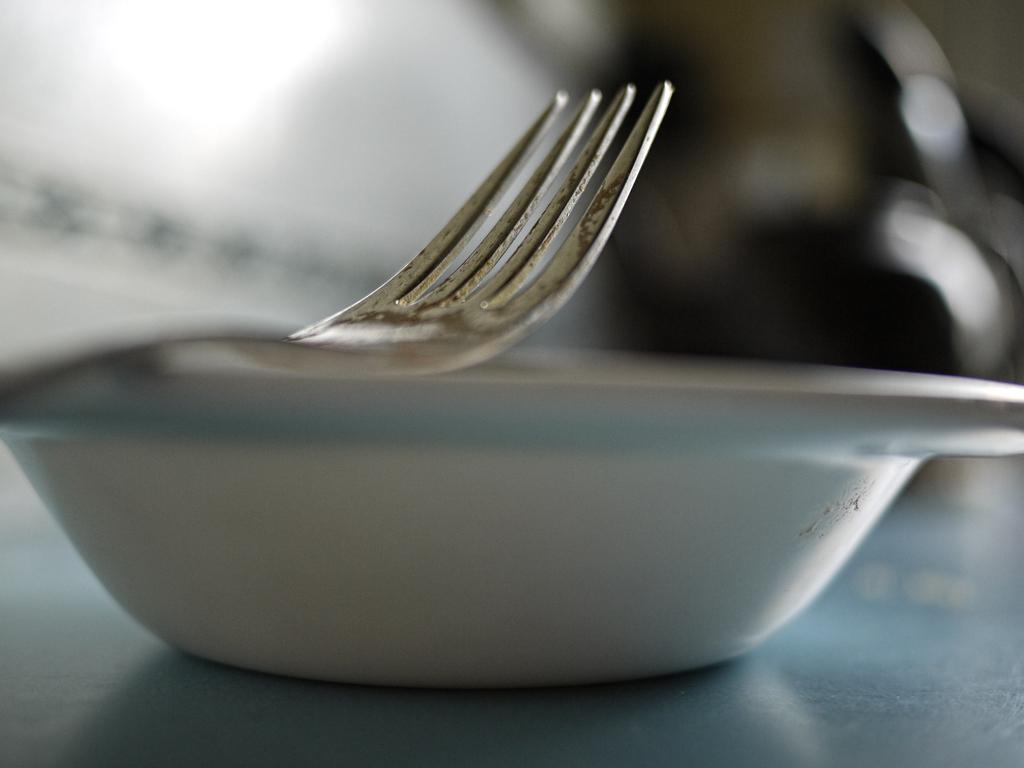Could you give a brief overview of what you see in this image? In this image there is a table on that table, there is a bowl on that bowl there is a fork. 